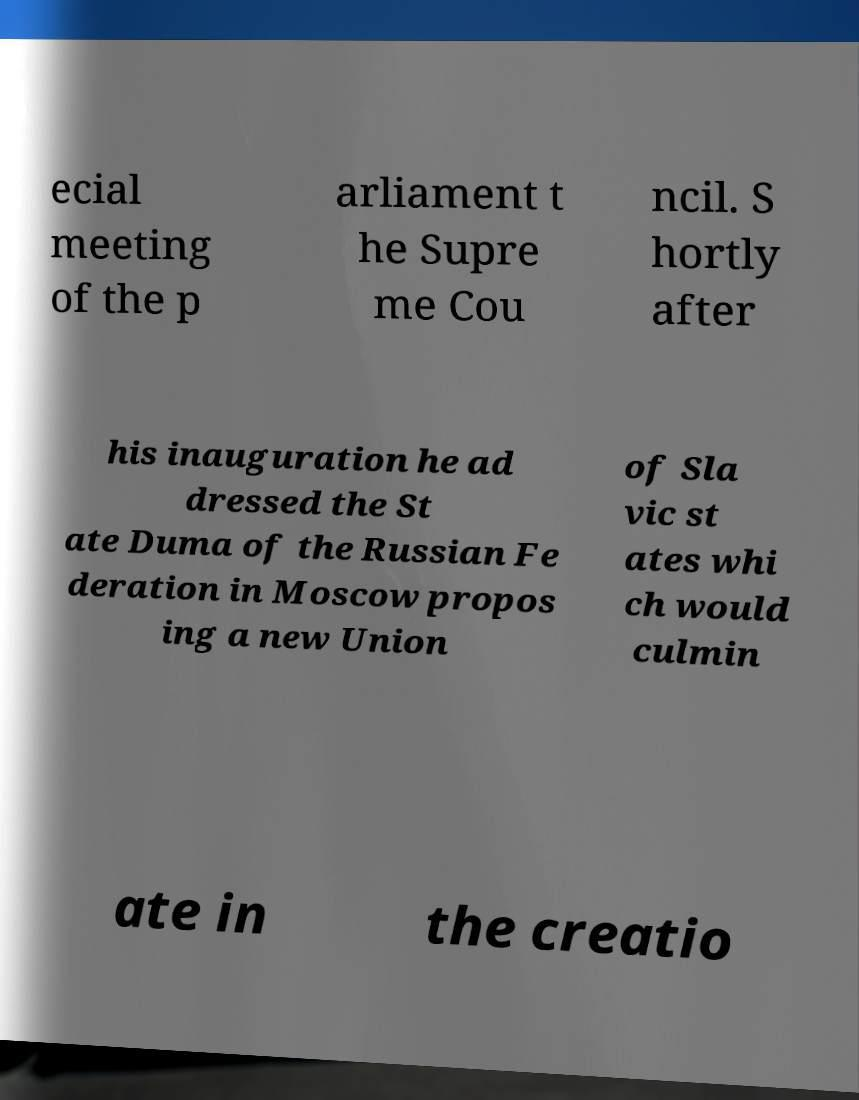Could you assist in decoding the text presented in this image and type it out clearly? ecial meeting of the p arliament t he Supre me Cou ncil. S hortly after his inauguration he ad dressed the St ate Duma of the Russian Fe deration in Moscow propos ing a new Union of Sla vic st ates whi ch would culmin ate in the creatio 